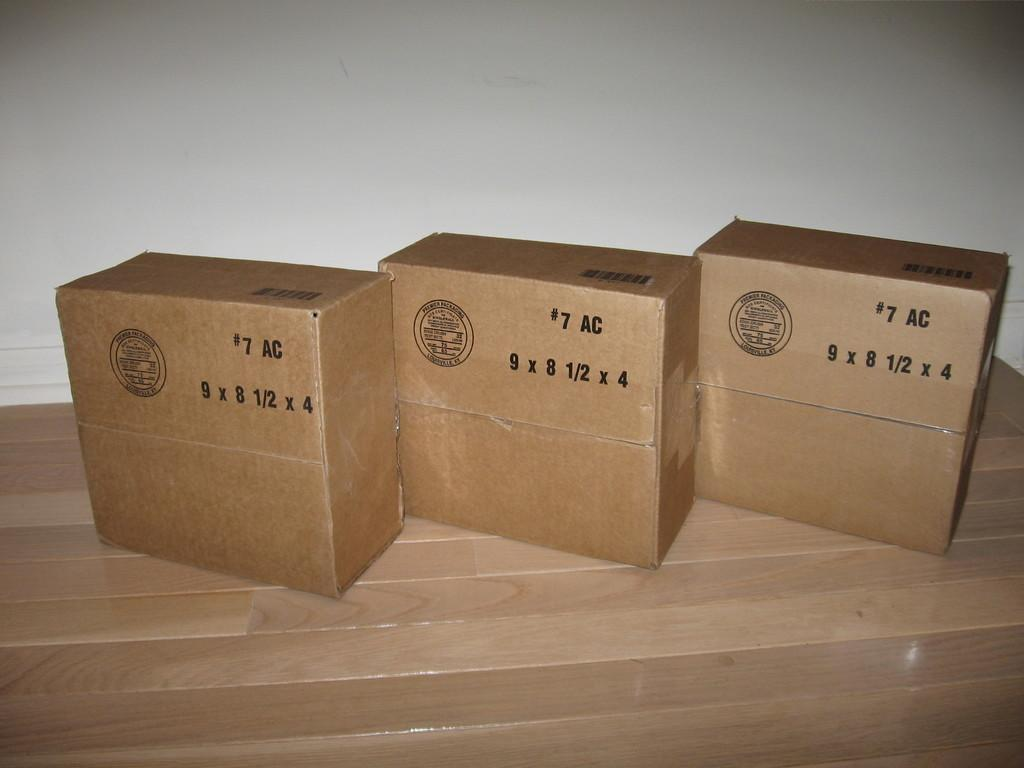Provide a one-sentence caption for the provided image. Three boxes made by Premier Packaging in Louisville, KY. 